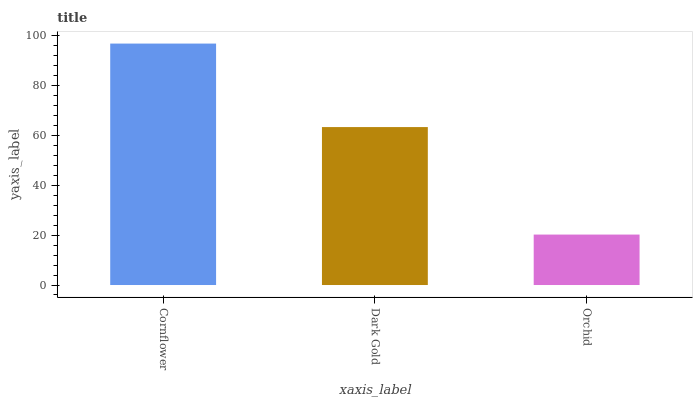Is Orchid the minimum?
Answer yes or no. Yes. Is Cornflower the maximum?
Answer yes or no. Yes. Is Dark Gold the minimum?
Answer yes or no. No. Is Dark Gold the maximum?
Answer yes or no. No. Is Cornflower greater than Dark Gold?
Answer yes or no. Yes. Is Dark Gold less than Cornflower?
Answer yes or no. Yes. Is Dark Gold greater than Cornflower?
Answer yes or no. No. Is Cornflower less than Dark Gold?
Answer yes or no. No. Is Dark Gold the high median?
Answer yes or no. Yes. Is Dark Gold the low median?
Answer yes or no. Yes. Is Orchid the high median?
Answer yes or no. No. Is Cornflower the low median?
Answer yes or no. No. 